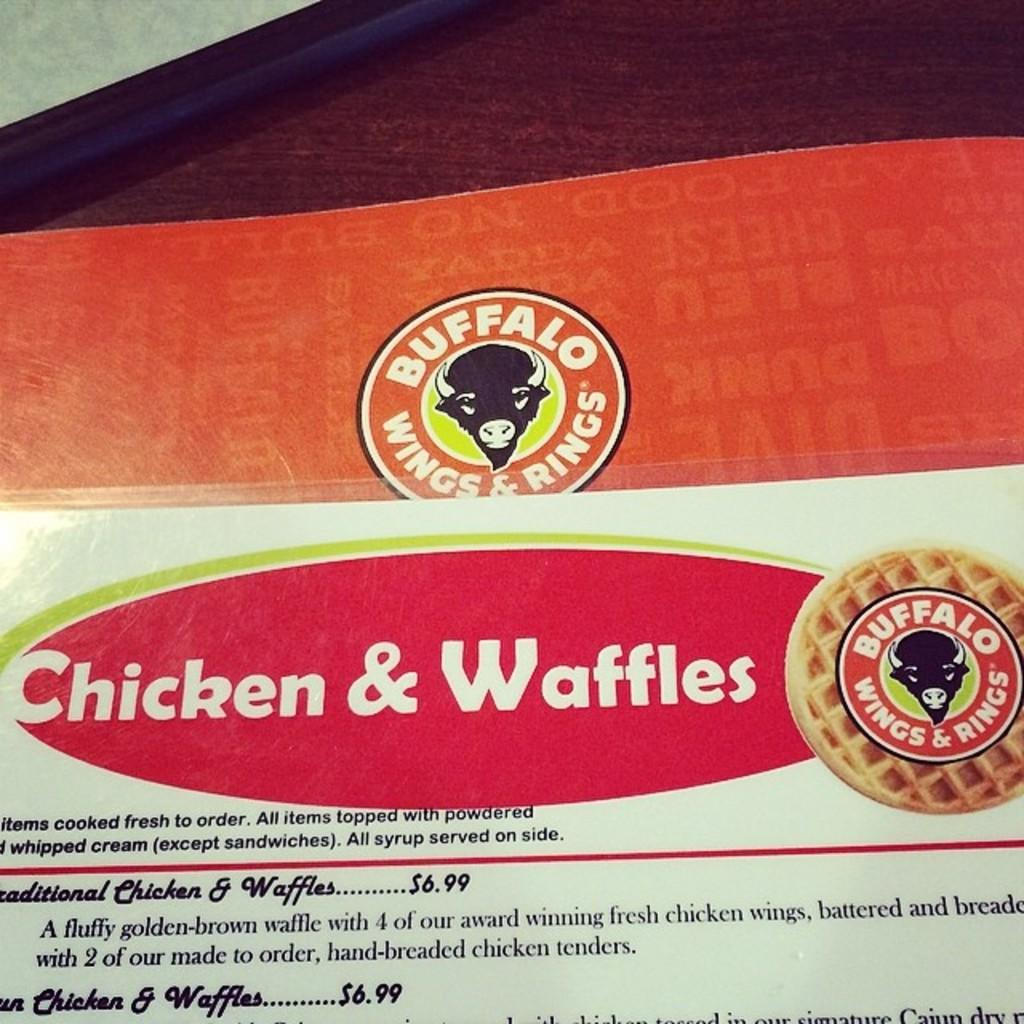What is the main object in the image? There is a card in the image. What can be found on the card? The card has text written on it and logos present on it. What type of surface is visible at the top of the image? There is a wooden surface at the top of the image. What type of arithmetic problem is being taught on the card? There is no arithmetic problem visible on the card in the image. How much noise is being made by the card in the image? The card in the image is not making any noise. 